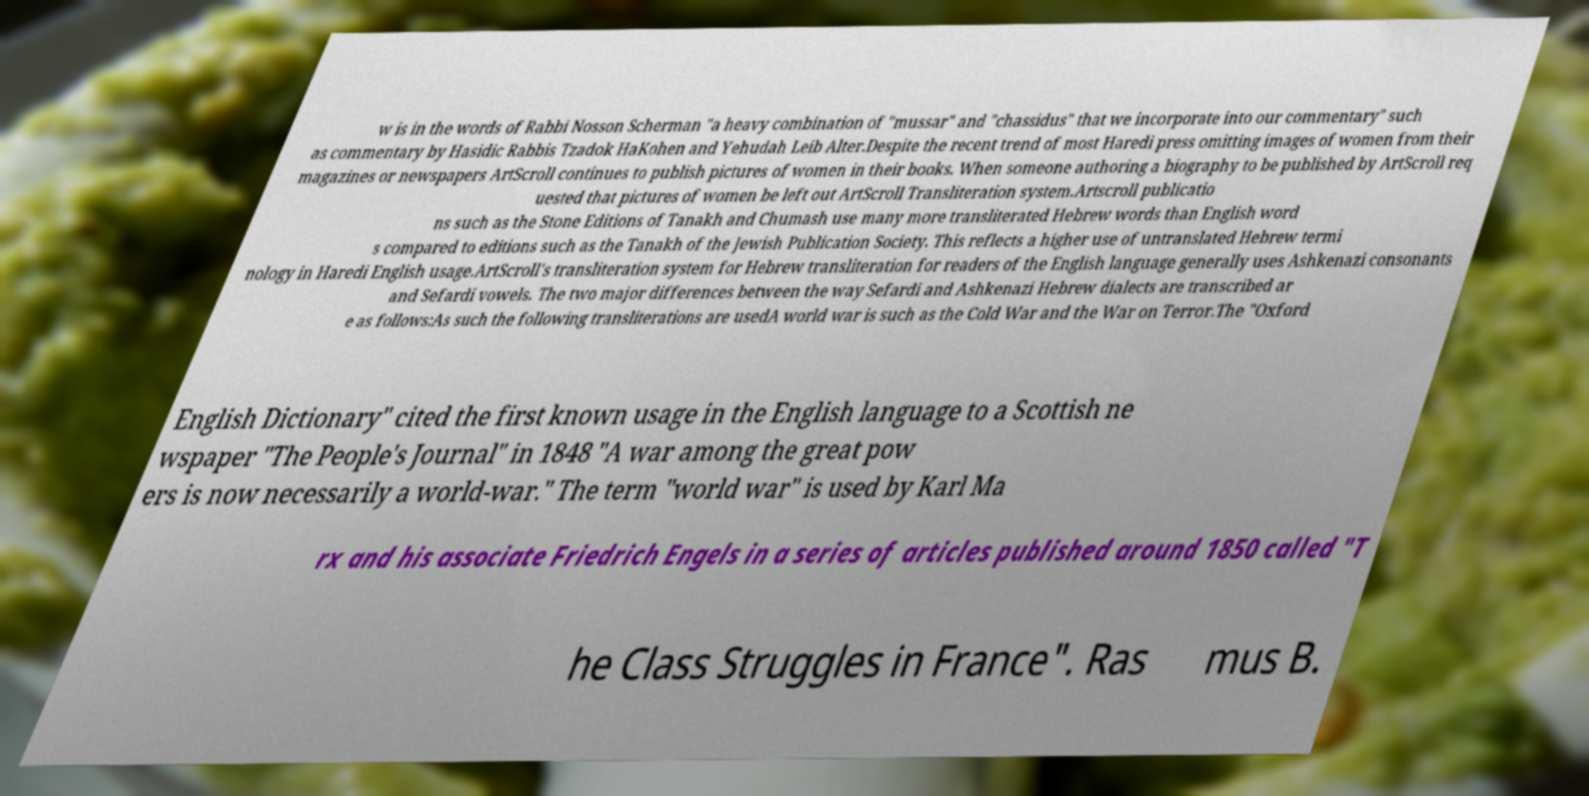What messages or text are displayed in this image? I need them in a readable, typed format. w is in the words of Rabbi Nosson Scherman "a heavy combination of "mussar" and "chassidus" that we incorporate into our commentary" such as commentary by Hasidic Rabbis Tzadok HaKohen and Yehudah Leib Alter.Despite the recent trend of most Haredi press omitting images of women from their magazines or newspapers ArtScroll continues to publish pictures of women in their books. When someone authoring a biography to be published by ArtScroll req uested that pictures of women be left out ArtScroll Transliteration system.Artscroll publicatio ns such as the Stone Editions of Tanakh and Chumash use many more transliterated Hebrew words than English word s compared to editions such as the Tanakh of the Jewish Publication Society. This reflects a higher use of untranslated Hebrew termi nology in Haredi English usage.ArtScroll's transliteration system for Hebrew transliteration for readers of the English language generally uses Ashkenazi consonants and Sefardi vowels. The two major differences between the way Sefardi and Ashkenazi Hebrew dialects are transcribed ar e as follows:As such the following transliterations are usedA world war is such as the Cold War and the War on Terror.The "Oxford English Dictionary" cited the first known usage in the English language to a Scottish ne wspaper "The People's Journal" in 1848 "A war among the great pow ers is now necessarily a world-war." The term "world war" is used by Karl Ma rx and his associate Friedrich Engels in a series of articles published around 1850 called "T he Class Struggles in France". Ras mus B. 